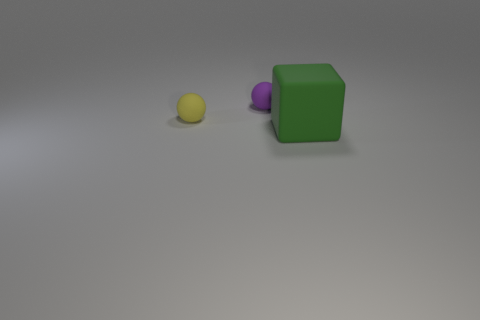Add 2 big green matte things. How many objects exist? 5 Subtract all balls. How many objects are left? 1 Subtract 0 brown spheres. How many objects are left? 3 Subtract 2 spheres. How many spheres are left? 0 Subtract all brown cubes. Subtract all cyan spheres. How many cubes are left? 1 Subtract all tiny yellow matte things. Subtract all purple spheres. How many objects are left? 1 Add 3 purple matte balls. How many purple matte balls are left? 4 Add 3 big green matte blocks. How many big green matte blocks exist? 4 Subtract all yellow balls. How many balls are left? 1 